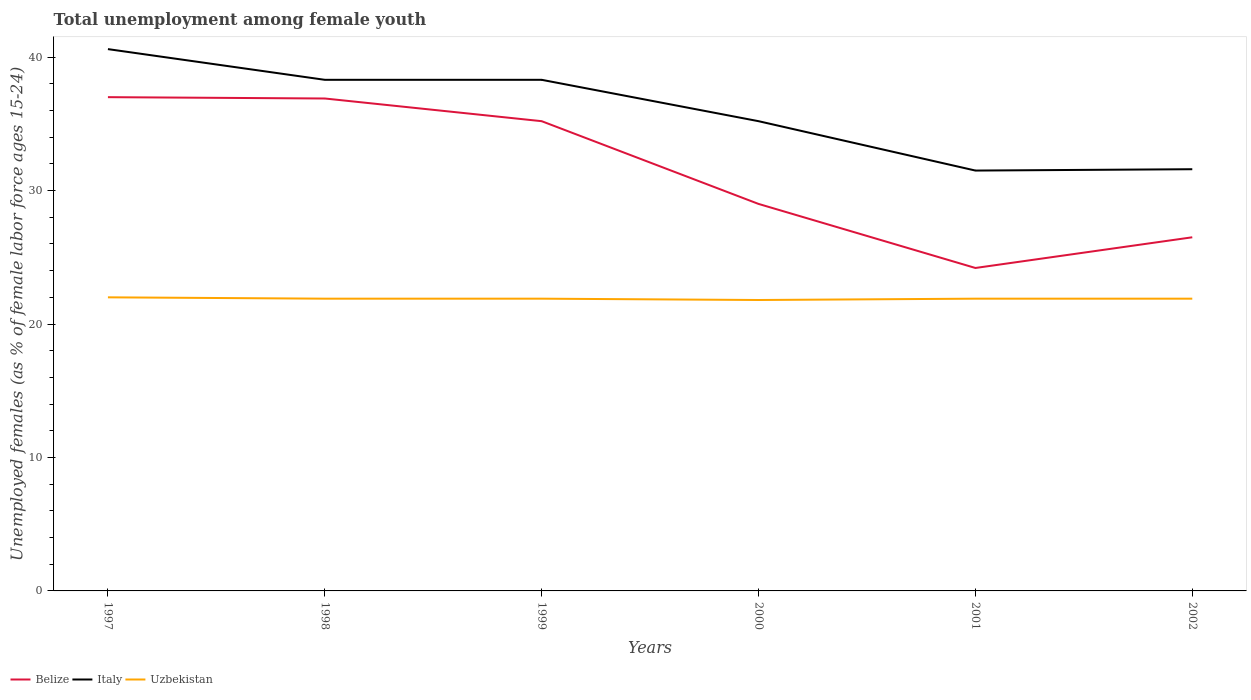How many different coloured lines are there?
Ensure brevity in your answer.  3. Is the number of lines equal to the number of legend labels?
Keep it short and to the point. Yes. Across all years, what is the maximum percentage of unemployed females in in Uzbekistan?
Give a very brief answer. 21.8. What is the total percentage of unemployed females in in Belize in the graph?
Keep it short and to the point. 12.7. What is the difference between the highest and the second highest percentage of unemployed females in in Belize?
Give a very brief answer. 12.8. What is the difference between two consecutive major ticks on the Y-axis?
Make the answer very short. 10. Does the graph contain any zero values?
Offer a very short reply. No. Where does the legend appear in the graph?
Your response must be concise. Bottom left. How are the legend labels stacked?
Your answer should be compact. Horizontal. What is the title of the graph?
Give a very brief answer. Total unemployment among female youth. Does "Singapore" appear as one of the legend labels in the graph?
Your answer should be compact. No. What is the label or title of the X-axis?
Give a very brief answer. Years. What is the label or title of the Y-axis?
Your answer should be compact. Unemployed females (as % of female labor force ages 15-24). What is the Unemployed females (as % of female labor force ages 15-24) in Italy in 1997?
Make the answer very short. 40.6. What is the Unemployed females (as % of female labor force ages 15-24) in Uzbekistan in 1997?
Your answer should be very brief. 22. What is the Unemployed females (as % of female labor force ages 15-24) in Belize in 1998?
Provide a short and direct response. 36.9. What is the Unemployed females (as % of female labor force ages 15-24) in Italy in 1998?
Your answer should be very brief. 38.3. What is the Unemployed females (as % of female labor force ages 15-24) of Uzbekistan in 1998?
Give a very brief answer. 21.9. What is the Unemployed females (as % of female labor force ages 15-24) of Belize in 1999?
Your response must be concise. 35.2. What is the Unemployed females (as % of female labor force ages 15-24) in Italy in 1999?
Your answer should be very brief. 38.3. What is the Unemployed females (as % of female labor force ages 15-24) in Uzbekistan in 1999?
Offer a terse response. 21.9. What is the Unemployed females (as % of female labor force ages 15-24) of Italy in 2000?
Your answer should be compact. 35.2. What is the Unemployed females (as % of female labor force ages 15-24) in Uzbekistan in 2000?
Provide a succinct answer. 21.8. What is the Unemployed females (as % of female labor force ages 15-24) of Belize in 2001?
Offer a very short reply. 24.2. What is the Unemployed females (as % of female labor force ages 15-24) in Italy in 2001?
Ensure brevity in your answer.  31.5. What is the Unemployed females (as % of female labor force ages 15-24) of Uzbekistan in 2001?
Give a very brief answer. 21.9. What is the Unemployed females (as % of female labor force ages 15-24) of Italy in 2002?
Keep it short and to the point. 31.6. What is the Unemployed females (as % of female labor force ages 15-24) of Uzbekistan in 2002?
Provide a succinct answer. 21.9. Across all years, what is the maximum Unemployed females (as % of female labor force ages 15-24) of Italy?
Your answer should be compact. 40.6. Across all years, what is the minimum Unemployed females (as % of female labor force ages 15-24) of Belize?
Provide a short and direct response. 24.2. Across all years, what is the minimum Unemployed females (as % of female labor force ages 15-24) of Italy?
Ensure brevity in your answer.  31.5. Across all years, what is the minimum Unemployed females (as % of female labor force ages 15-24) of Uzbekistan?
Offer a terse response. 21.8. What is the total Unemployed females (as % of female labor force ages 15-24) in Belize in the graph?
Offer a terse response. 188.8. What is the total Unemployed females (as % of female labor force ages 15-24) in Italy in the graph?
Provide a succinct answer. 215.5. What is the total Unemployed females (as % of female labor force ages 15-24) in Uzbekistan in the graph?
Provide a succinct answer. 131.4. What is the difference between the Unemployed females (as % of female labor force ages 15-24) of Italy in 1997 and that in 1998?
Give a very brief answer. 2.3. What is the difference between the Unemployed females (as % of female labor force ages 15-24) of Uzbekistan in 1997 and that in 1998?
Keep it short and to the point. 0.1. What is the difference between the Unemployed females (as % of female labor force ages 15-24) in Belize in 1997 and that in 1999?
Your answer should be compact. 1.8. What is the difference between the Unemployed females (as % of female labor force ages 15-24) in Italy in 1997 and that in 1999?
Ensure brevity in your answer.  2.3. What is the difference between the Unemployed females (as % of female labor force ages 15-24) of Italy in 1997 and that in 2000?
Your answer should be compact. 5.4. What is the difference between the Unemployed females (as % of female labor force ages 15-24) of Italy in 1997 and that in 2001?
Offer a terse response. 9.1. What is the difference between the Unemployed females (as % of female labor force ages 15-24) of Italy in 1997 and that in 2002?
Your response must be concise. 9. What is the difference between the Unemployed females (as % of female labor force ages 15-24) in Italy in 1998 and that in 1999?
Provide a succinct answer. 0. What is the difference between the Unemployed females (as % of female labor force ages 15-24) in Uzbekistan in 1998 and that in 1999?
Provide a short and direct response. 0. What is the difference between the Unemployed females (as % of female labor force ages 15-24) of Belize in 1998 and that in 2000?
Make the answer very short. 7.9. What is the difference between the Unemployed females (as % of female labor force ages 15-24) in Uzbekistan in 1998 and that in 2000?
Provide a succinct answer. 0.1. What is the difference between the Unemployed females (as % of female labor force ages 15-24) in Belize in 1998 and that in 2001?
Provide a short and direct response. 12.7. What is the difference between the Unemployed females (as % of female labor force ages 15-24) of Uzbekistan in 1998 and that in 2001?
Your response must be concise. 0. What is the difference between the Unemployed females (as % of female labor force ages 15-24) of Belize in 1998 and that in 2002?
Make the answer very short. 10.4. What is the difference between the Unemployed females (as % of female labor force ages 15-24) in Italy in 1998 and that in 2002?
Provide a short and direct response. 6.7. What is the difference between the Unemployed females (as % of female labor force ages 15-24) of Belize in 1999 and that in 2000?
Make the answer very short. 6.2. What is the difference between the Unemployed females (as % of female labor force ages 15-24) in Italy in 1999 and that in 2000?
Offer a terse response. 3.1. What is the difference between the Unemployed females (as % of female labor force ages 15-24) of Italy in 1999 and that in 2001?
Your answer should be very brief. 6.8. What is the difference between the Unemployed females (as % of female labor force ages 15-24) of Uzbekistan in 1999 and that in 2001?
Provide a short and direct response. 0. What is the difference between the Unemployed females (as % of female labor force ages 15-24) in Belize in 1999 and that in 2002?
Make the answer very short. 8.7. What is the difference between the Unemployed females (as % of female labor force ages 15-24) of Italy in 1999 and that in 2002?
Your response must be concise. 6.7. What is the difference between the Unemployed females (as % of female labor force ages 15-24) in Belize in 2000 and that in 2001?
Provide a succinct answer. 4.8. What is the difference between the Unemployed females (as % of female labor force ages 15-24) in Italy in 2000 and that in 2001?
Provide a succinct answer. 3.7. What is the difference between the Unemployed females (as % of female labor force ages 15-24) of Uzbekistan in 2000 and that in 2001?
Provide a short and direct response. -0.1. What is the difference between the Unemployed females (as % of female labor force ages 15-24) of Uzbekistan in 2000 and that in 2002?
Provide a succinct answer. -0.1. What is the difference between the Unemployed females (as % of female labor force ages 15-24) of Italy in 2001 and that in 2002?
Ensure brevity in your answer.  -0.1. What is the difference between the Unemployed females (as % of female labor force ages 15-24) in Belize in 1997 and the Unemployed females (as % of female labor force ages 15-24) in Italy in 1998?
Offer a terse response. -1.3. What is the difference between the Unemployed females (as % of female labor force ages 15-24) in Italy in 1997 and the Unemployed females (as % of female labor force ages 15-24) in Uzbekistan in 1998?
Make the answer very short. 18.7. What is the difference between the Unemployed females (as % of female labor force ages 15-24) in Italy in 1997 and the Unemployed females (as % of female labor force ages 15-24) in Uzbekistan in 1999?
Offer a terse response. 18.7. What is the difference between the Unemployed females (as % of female labor force ages 15-24) in Belize in 1997 and the Unemployed females (as % of female labor force ages 15-24) in Italy in 2000?
Ensure brevity in your answer.  1.8. What is the difference between the Unemployed females (as % of female labor force ages 15-24) in Belize in 1997 and the Unemployed females (as % of female labor force ages 15-24) in Uzbekistan in 2000?
Provide a succinct answer. 15.2. What is the difference between the Unemployed females (as % of female labor force ages 15-24) in Belize in 1997 and the Unemployed females (as % of female labor force ages 15-24) in Italy in 2001?
Give a very brief answer. 5.5. What is the difference between the Unemployed females (as % of female labor force ages 15-24) in Italy in 1997 and the Unemployed females (as % of female labor force ages 15-24) in Uzbekistan in 2001?
Your answer should be compact. 18.7. What is the difference between the Unemployed females (as % of female labor force ages 15-24) of Belize in 1997 and the Unemployed females (as % of female labor force ages 15-24) of Uzbekistan in 2002?
Give a very brief answer. 15.1. What is the difference between the Unemployed females (as % of female labor force ages 15-24) of Italy in 1997 and the Unemployed females (as % of female labor force ages 15-24) of Uzbekistan in 2002?
Provide a succinct answer. 18.7. What is the difference between the Unemployed females (as % of female labor force ages 15-24) of Belize in 1998 and the Unemployed females (as % of female labor force ages 15-24) of Uzbekistan in 1999?
Ensure brevity in your answer.  15. What is the difference between the Unemployed females (as % of female labor force ages 15-24) in Italy in 1998 and the Unemployed females (as % of female labor force ages 15-24) in Uzbekistan in 1999?
Provide a succinct answer. 16.4. What is the difference between the Unemployed females (as % of female labor force ages 15-24) in Belize in 1998 and the Unemployed females (as % of female labor force ages 15-24) in Italy in 2000?
Provide a succinct answer. 1.7. What is the difference between the Unemployed females (as % of female labor force ages 15-24) in Belize in 1998 and the Unemployed females (as % of female labor force ages 15-24) in Uzbekistan in 2000?
Provide a short and direct response. 15.1. What is the difference between the Unemployed females (as % of female labor force ages 15-24) of Italy in 1998 and the Unemployed females (as % of female labor force ages 15-24) of Uzbekistan in 2001?
Your answer should be very brief. 16.4. What is the difference between the Unemployed females (as % of female labor force ages 15-24) of Belize in 1998 and the Unemployed females (as % of female labor force ages 15-24) of Italy in 2002?
Make the answer very short. 5.3. What is the difference between the Unemployed females (as % of female labor force ages 15-24) in Belize in 1998 and the Unemployed females (as % of female labor force ages 15-24) in Uzbekistan in 2002?
Your response must be concise. 15. What is the difference between the Unemployed females (as % of female labor force ages 15-24) in Belize in 1999 and the Unemployed females (as % of female labor force ages 15-24) in Uzbekistan in 2000?
Give a very brief answer. 13.4. What is the difference between the Unemployed females (as % of female labor force ages 15-24) of Belize in 1999 and the Unemployed females (as % of female labor force ages 15-24) of Italy in 2002?
Provide a short and direct response. 3.6. What is the difference between the Unemployed females (as % of female labor force ages 15-24) of Italy in 1999 and the Unemployed females (as % of female labor force ages 15-24) of Uzbekistan in 2002?
Provide a succinct answer. 16.4. What is the difference between the Unemployed females (as % of female labor force ages 15-24) in Italy in 2000 and the Unemployed females (as % of female labor force ages 15-24) in Uzbekistan in 2001?
Offer a very short reply. 13.3. What is the difference between the Unemployed females (as % of female labor force ages 15-24) in Belize in 2000 and the Unemployed females (as % of female labor force ages 15-24) in Italy in 2002?
Offer a very short reply. -2.6. What is the difference between the Unemployed females (as % of female labor force ages 15-24) of Italy in 2000 and the Unemployed females (as % of female labor force ages 15-24) of Uzbekistan in 2002?
Your answer should be very brief. 13.3. What is the difference between the Unemployed females (as % of female labor force ages 15-24) in Belize in 2001 and the Unemployed females (as % of female labor force ages 15-24) in Italy in 2002?
Offer a very short reply. -7.4. What is the difference between the Unemployed females (as % of female labor force ages 15-24) in Belize in 2001 and the Unemployed females (as % of female labor force ages 15-24) in Uzbekistan in 2002?
Keep it short and to the point. 2.3. What is the average Unemployed females (as % of female labor force ages 15-24) of Belize per year?
Your answer should be very brief. 31.47. What is the average Unemployed females (as % of female labor force ages 15-24) in Italy per year?
Offer a very short reply. 35.92. What is the average Unemployed females (as % of female labor force ages 15-24) of Uzbekistan per year?
Give a very brief answer. 21.9. In the year 1997, what is the difference between the Unemployed females (as % of female labor force ages 15-24) of Belize and Unemployed females (as % of female labor force ages 15-24) of Italy?
Ensure brevity in your answer.  -3.6. In the year 1997, what is the difference between the Unemployed females (as % of female labor force ages 15-24) of Belize and Unemployed females (as % of female labor force ages 15-24) of Uzbekistan?
Your answer should be compact. 15. In the year 1998, what is the difference between the Unemployed females (as % of female labor force ages 15-24) in Belize and Unemployed females (as % of female labor force ages 15-24) in Uzbekistan?
Give a very brief answer. 15. In the year 1998, what is the difference between the Unemployed females (as % of female labor force ages 15-24) of Italy and Unemployed females (as % of female labor force ages 15-24) of Uzbekistan?
Offer a terse response. 16.4. In the year 1999, what is the difference between the Unemployed females (as % of female labor force ages 15-24) in Belize and Unemployed females (as % of female labor force ages 15-24) in Uzbekistan?
Your response must be concise. 13.3. In the year 1999, what is the difference between the Unemployed females (as % of female labor force ages 15-24) of Italy and Unemployed females (as % of female labor force ages 15-24) of Uzbekistan?
Keep it short and to the point. 16.4. In the year 2000, what is the difference between the Unemployed females (as % of female labor force ages 15-24) in Belize and Unemployed females (as % of female labor force ages 15-24) in Italy?
Offer a terse response. -6.2. In the year 2002, what is the difference between the Unemployed females (as % of female labor force ages 15-24) of Belize and Unemployed females (as % of female labor force ages 15-24) of Italy?
Provide a short and direct response. -5.1. In the year 2002, what is the difference between the Unemployed females (as % of female labor force ages 15-24) in Belize and Unemployed females (as % of female labor force ages 15-24) in Uzbekistan?
Give a very brief answer. 4.6. What is the ratio of the Unemployed females (as % of female labor force ages 15-24) in Belize in 1997 to that in 1998?
Your answer should be very brief. 1. What is the ratio of the Unemployed females (as % of female labor force ages 15-24) of Italy in 1997 to that in 1998?
Your answer should be compact. 1.06. What is the ratio of the Unemployed females (as % of female labor force ages 15-24) of Uzbekistan in 1997 to that in 1998?
Keep it short and to the point. 1. What is the ratio of the Unemployed females (as % of female labor force ages 15-24) of Belize in 1997 to that in 1999?
Your response must be concise. 1.05. What is the ratio of the Unemployed females (as % of female labor force ages 15-24) of Italy in 1997 to that in 1999?
Keep it short and to the point. 1.06. What is the ratio of the Unemployed females (as % of female labor force ages 15-24) in Uzbekistan in 1997 to that in 1999?
Ensure brevity in your answer.  1. What is the ratio of the Unemployed females (as % of female labor force ages 15-24) in Belize in 1997 to that in 2000?
Offer a very short reply. 1.28. What is the ratio of the Unemployed females (as % of female labor force ages 15-24) in Italy in 1997 to that in 2000?
Keep it short and to the point. 1.15. What is the ratio of the Unemployed females (as % of female labor force ages 15-24) of Uzbekistan in 1997 to that in 2000?
Provide a succinct answer. 1.01. What is the ratio of the Unemployed females (as % of female labor force ages 15-24) of Belize in 1997 to that in 2001?
Offer a very short reply. 1.53. What is the ratio of the Unemployed females (as % of female labor force ages 15-24) of Italy in 1997 to that in 2001?
Make the answer very short. 1.29. What is the ratio of the Unemployed females (as % of female labor force ages 15-24) in Uzbekistan in 1997 to that in 2001?
Provide a succinct answer. 1. What is the ratio of the Unemployed females (as % of female labor force ages 15-24) in Belize in 1997 to that in 2002?
Your answer should be compact. 1.4. What is the ratio of the Unemployed females (as % of female labor force ages 15-24) of Italy in 1997 to that in 2002?
Ensure brevity in your answer.  1.28. What is the ratio of the Unemployed females (as % of female labor force ages 15-24) of Belize in 1998 to that in 1999?
Your response must be concise. 1.05. What is the ratio of the Unemployed females (as % of female labor force ages 15-24) of Belize in 1998 to that in 2000?
Give a very brief answer. 1.27. What is the ratio of the Unemployed females (as % of female labor force ages 15-24) in Italy in 1998 to that in 2000?
Your answer should be compact. 1.09. What is the ratio of the Unemployed females (as % of female labor force ages 15-24) of Belize in 1998 to that in 2001?
Your answer should be very brief. 1.52. What is the ratio of the Unemployed females (as % of female labor force ages 15-24) of Italy in 1998 to that in 2001?
Offer a terse response. 1.22. What is the ratio of the Unemployed females (as % of female labor force ages 15-24) in Uzbekistan in 1998 to that in 2001?
Your response must be concise. 1. What is the ratio of the Unemployed females (as % of female labor force ages 15-24) in Belize in 1998 to that in 2002?
Provide a short and direct response. 1.39. What is the ratio of the Unemployed females (as % of female labor force ages 15-24) in Italy in 1998 to that in 2002?
Make the answer very short. 1.21. What is the ratio of the Unemployed females (as % of female labor force ages 15-24) of Uzbekistan in 1998 to that in 2002?
Your answer should be compact. 1. What is the ratio of the Unemployed females (as % of female labor force ages 15-24) in Belize in 1999 to that in 2000?
Ensure brevity in your answer.  1.21. What is the ratio of the Unemployed females (as % of female labor force ages 15-24) of Italy in 1999 to that in 2000?
Your answer should be compact. 1.09. What is the ratio of the Unemployed females (as % of female labor force ages 15-24) of Belize in 1999 to that in 2001?
Provide a short and direct response. 1.45. What is the ratio of the Unemployed females (as % of female labor force ages 15-24) in Italy in 1999 to that in 2001?
Make the answer very short. 1.22. What is the ratio of the Unemployed females (as % of female labor force ages 15-24) in Belize in 1999 to that in 2002?
Provide a succinct answer. 1.33. What is the ratio of the Unemployed females (as % of female labor force ages 15-24) of Italy in 1999 to that in 2002?
Give a very brief answer. 1.21. What is the ratio of the Unemployed females (as % of female labor force ages 15-24) of Belize in 2000 to that in 2001?
Make the answer very short. 1.2. What is the ratio of the Unemployed females (as % of female labor force ages 15-24) of Italy in 2000 to that in 2001?
Provide a succinct answer. 1.12. What is the ratio of the Unemployed females (as % of female labor force ages 15-24) of Uzbekistan in 2000 to that in 2001?
Your answer should be compact. 1. What is the ratio of the Unemployed females (as % of female labor force ages 15-24) in Belize in 2000 to that in 2002?
Give a very brief answer. 1.09. What is the ratio of the Unemployed females (as % of female labor force ages 15-24) of Italy in 2000 to that in 2002?
Ensure brevity in your answer.  1.11. What is the ratio of the Unemployed females (as % of female labor force ages 15-24) of Belize in 2001 to that in 2002?
Keep it short and to the point. 0.91. What is the ratio of the Unemployed females (as % of female labor force ages 15-24) in Italy in 2001 to that in 2002?
Ensure brevity in your answer.  1. What is the difference between the highest and the second highest Unemployed females (as % of female labor force ages 15-24) in Belize?
Make the answer very short. 0.1. What is the difference between the highest and the second highest Unemployed females (as % of female labor force ages 15-24) of Italy?
Give a very brief answer. 2.3. What is the difference between the highest and the lowest Unemployed females (as % of female labor force ages 15-24) of Italy?
Offer a very short reply. 9.1. 